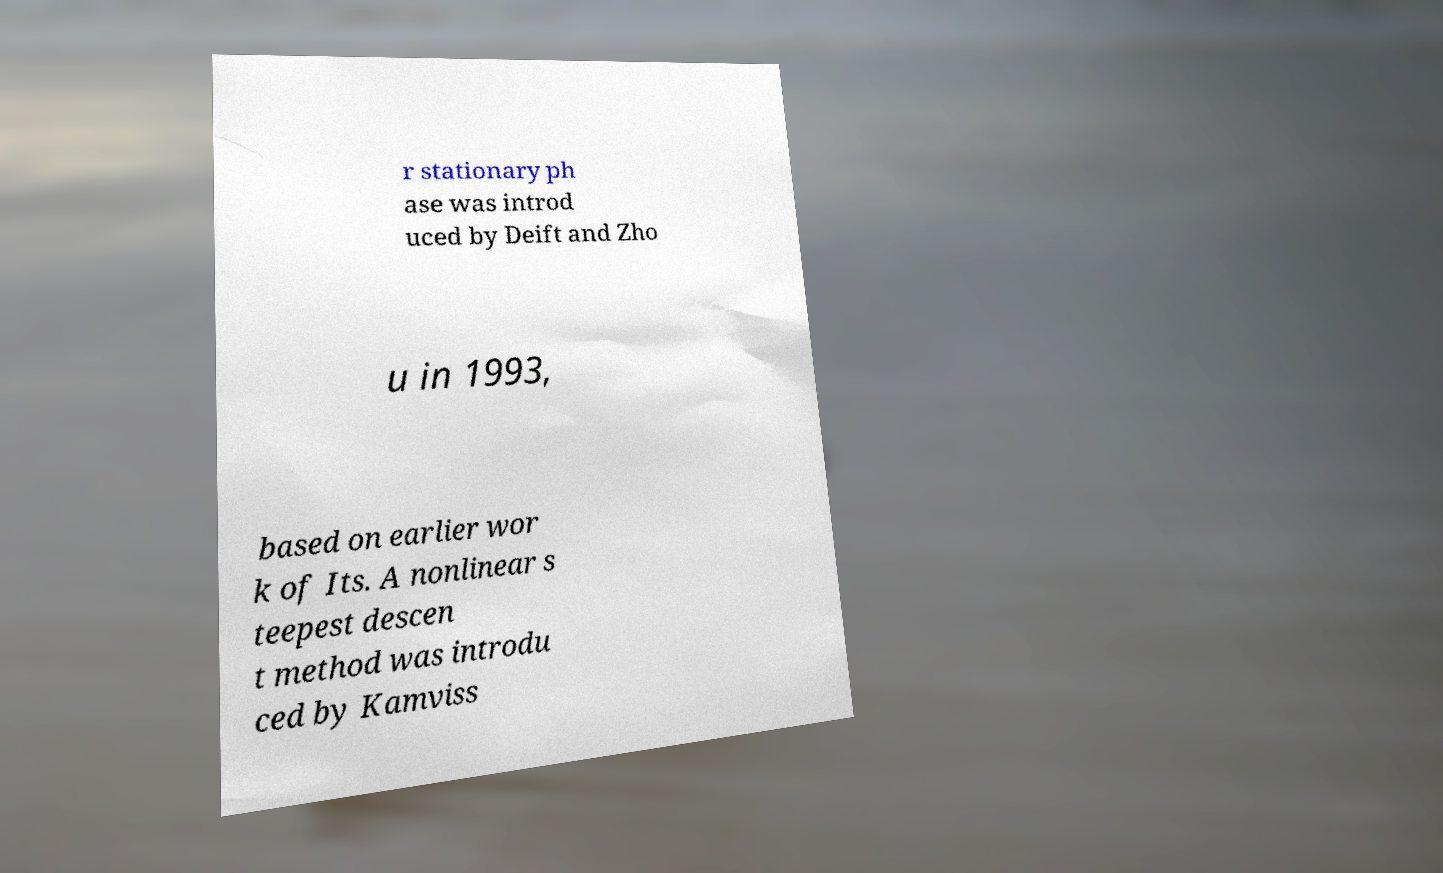I need the written content from this picture converted into text. Can you do that? r stationary ph ase was introd uced by Deift and Zho u in 1993, based on earlier wor k of Its. A nonlinear s teepest descen t method was introdu ced by Kamviss 